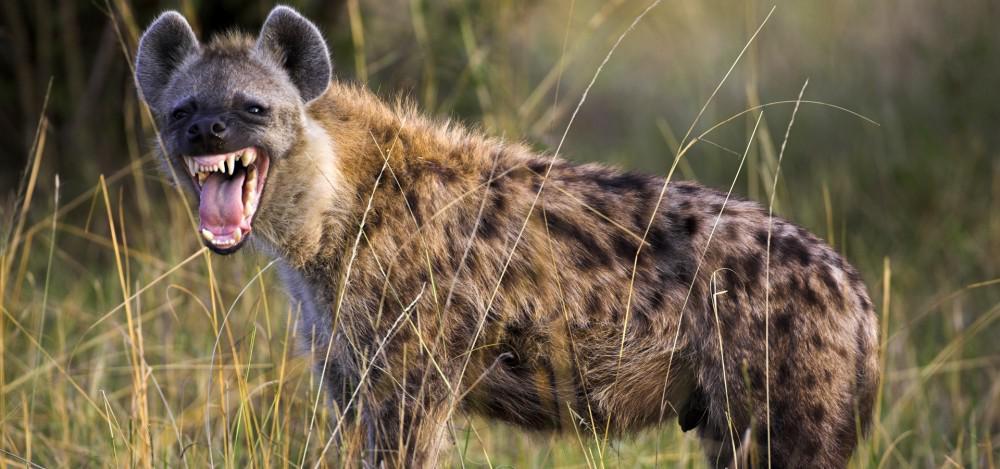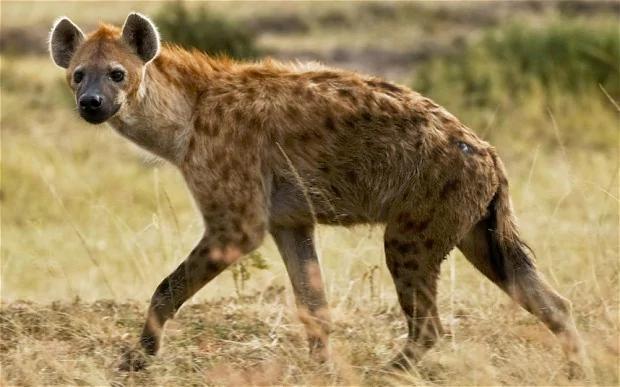The first image is the image on the left, the second image is the image on the right. For the images shown, is this caption "In at least one image there is a single hyena with an open mouth showing its teeth." true? Answer yes or no. Yes. The first image is the image on the left, the second image is the image on the right. For the images displayed, is the sentence "There are only two hyenas." factually correct? Answer yes or no. Yes. 